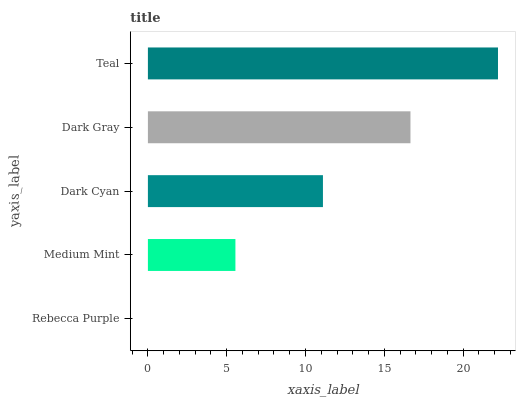Is Rebecca Purple the minimum?
Answer yes or no. Yes. Is Teal the maximum?
Answer yes or no. Yes. Is Medium Mint the minimum?
Answer yes or no. No. Is Medium Mint the maximum?
Answer yes or no. No. Is Medium Mint greater than Rebecca Purple?
Answer yes or no. Yes. Is Rebecca Purple less than Medium Mint?
Answer yes or no. Yes. Is Rebecca Purple greater than Medium Mint?
Answer yes or no. No. Is Medium Mint less than Rebecca Purple?
Answer yes or no. No. Is Dark Cyan the high median?
Answer yes or no. Yes. Is Dark Cyan the low median?
Answer yes or no. Yes. Is Teal the high median?
Answer yes or no. No. Is Teal the low median?
Answer yes or no. No. 